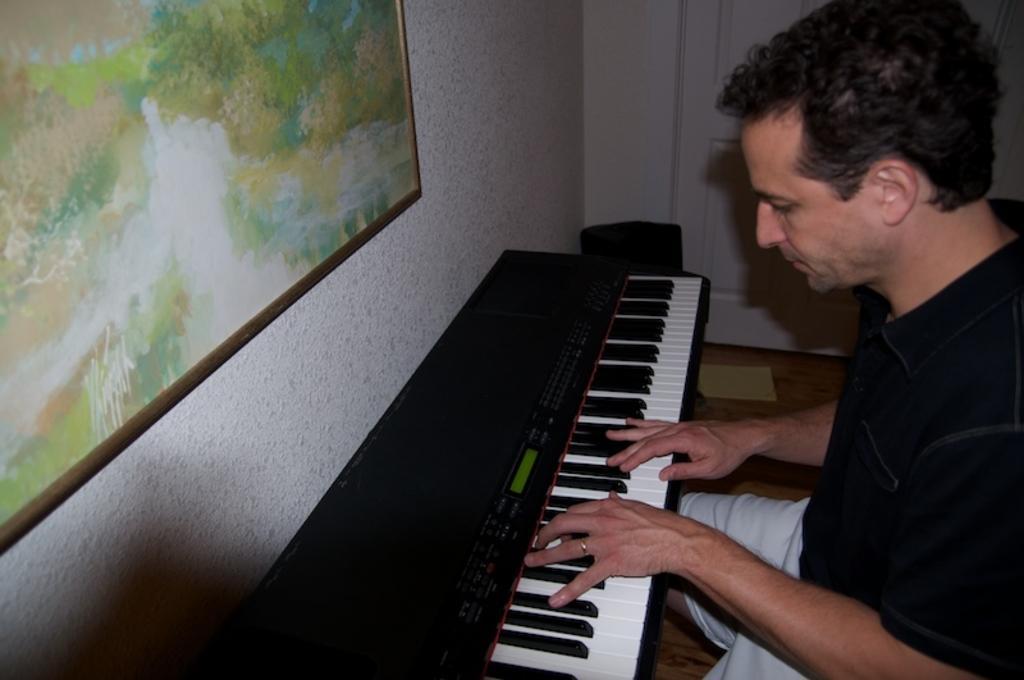Could you give a brief overview of what you see in this image? This picture shows a man playing piano and we see a poster on the wall 